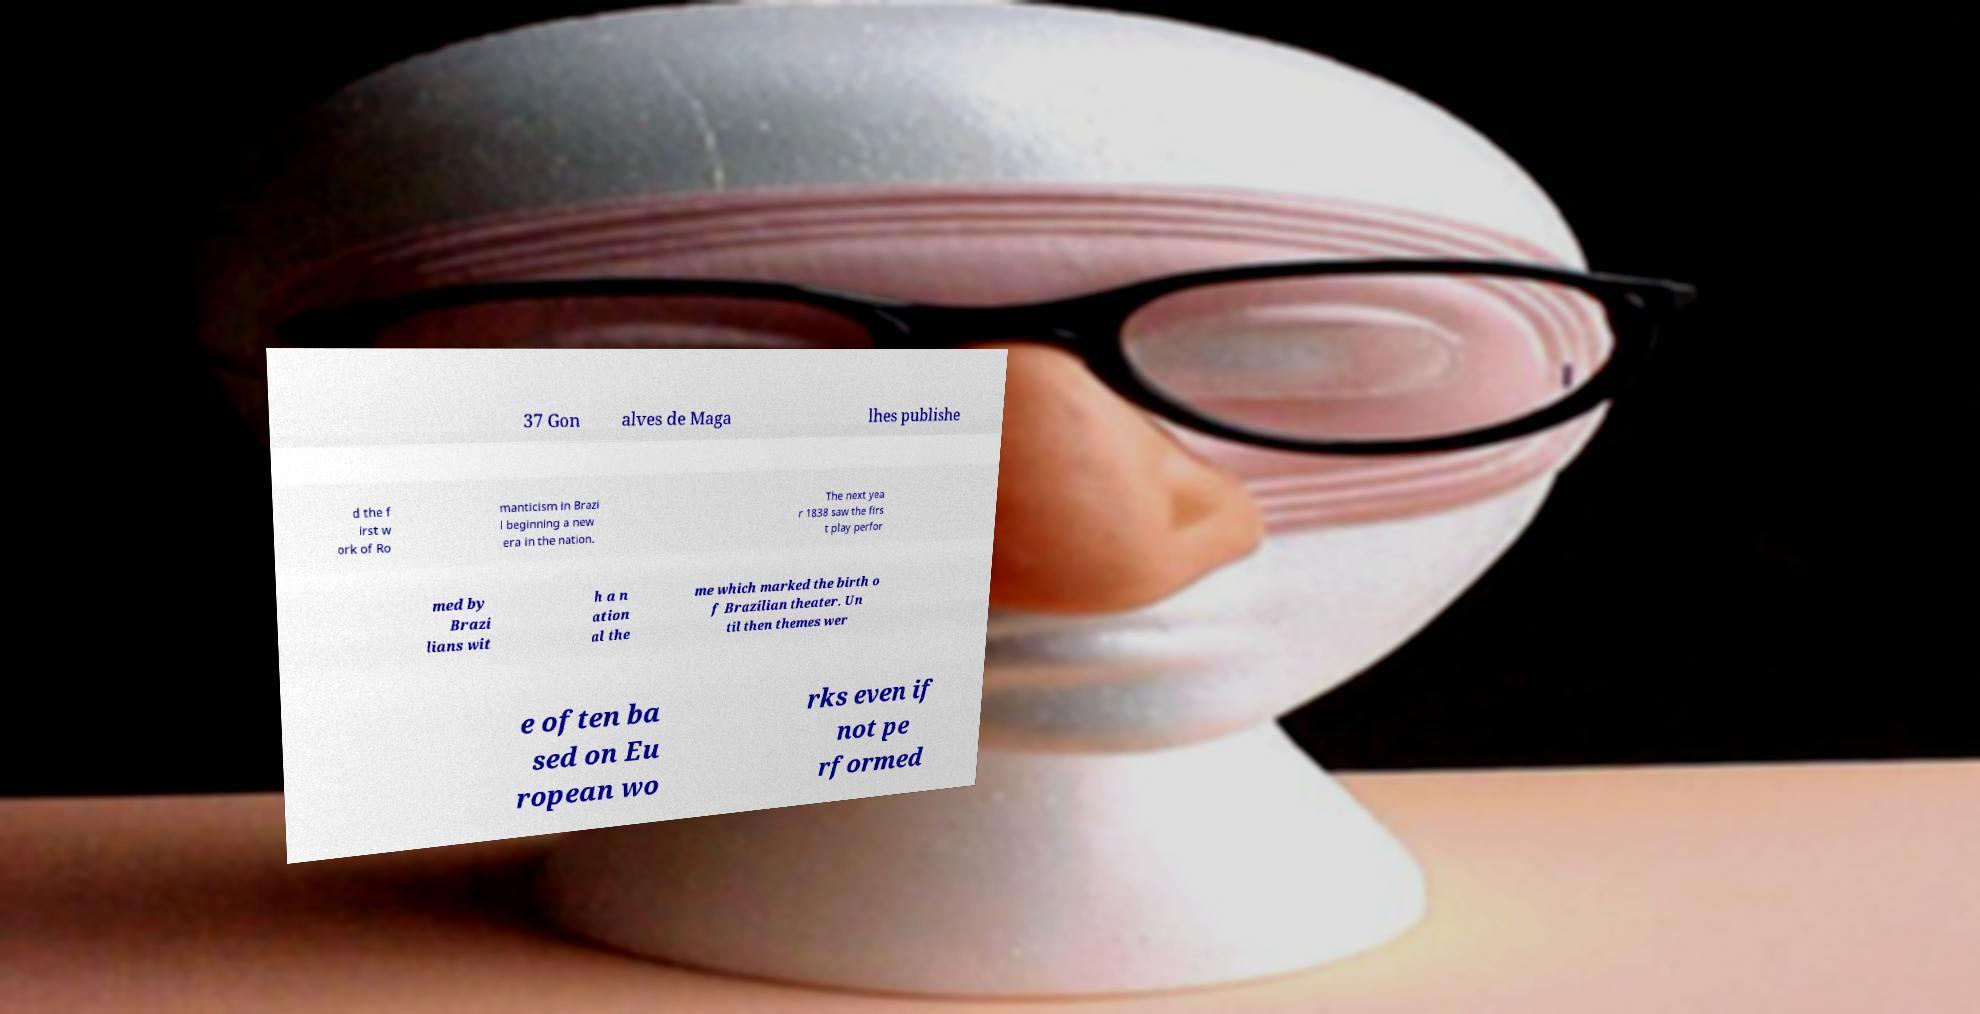Please read and relay the text visible in this image. What does it say? 37 Gon alves de Maga lhes publishe d the f irst w ork of Ro manticism in Brazi l beginning a new era in the nation. The next yea r 1838 saw the firs t play perfor med by Brazi lians wit h a n ation al the me which marked the birth o f Brazilian theater. Un til then themes wer e often ba sed on Eu ropean wo rks even if not pe rformed 